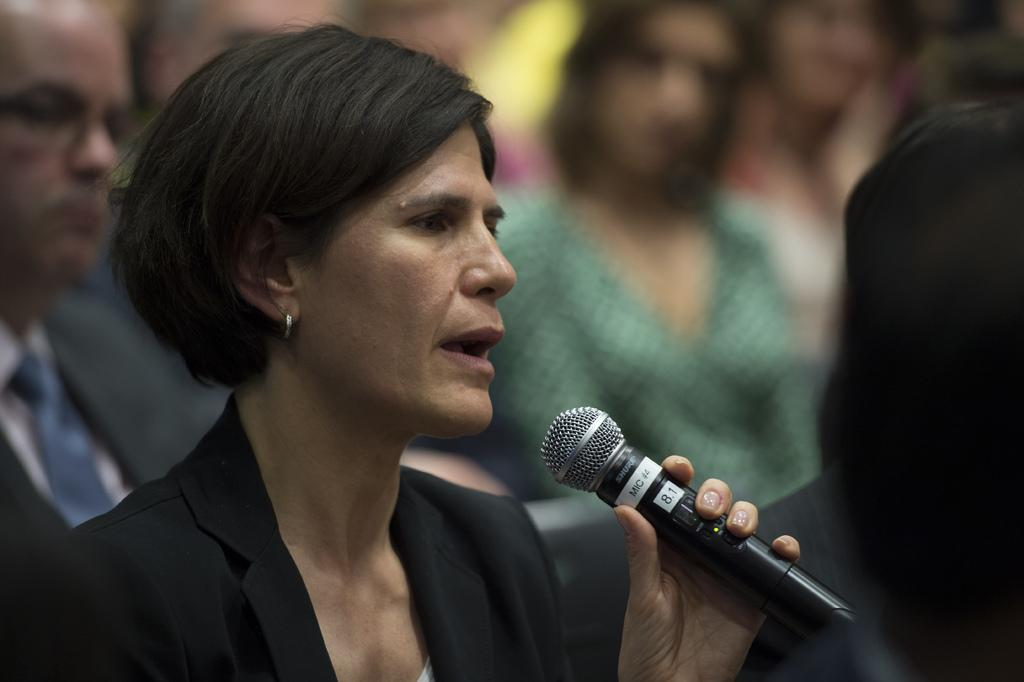Who is the main subject in the image? There is a woman in the image. What is the woman holding in the image? The woman is holding a microphone. Can you describe the background of the image? There are people visible in the background of the image. How many bikes are parked next to the woman in the image? There are no bikes visible in the image. What type of fang can be seen on the woman's face in the image? There is no fang present on the woman's face in the image. 